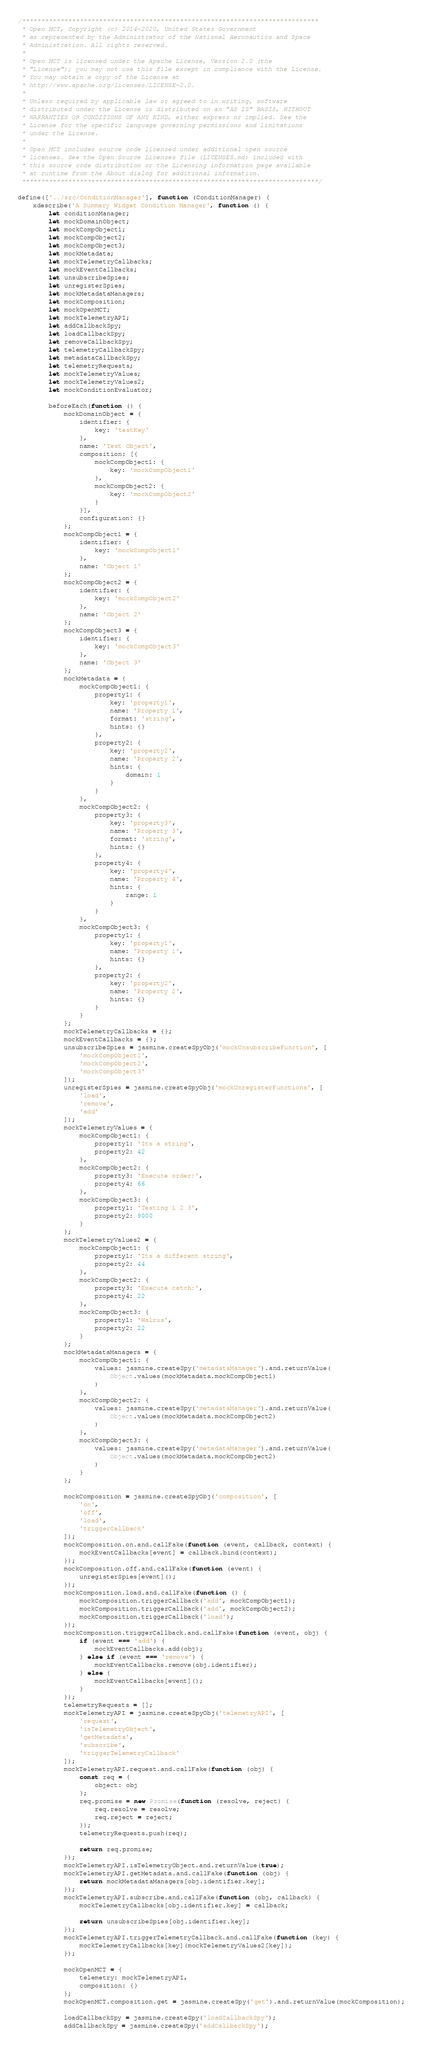Convert code to text. <code><loc_0><loc_0><loc_500><loc_500><_JavaScript_>/*****************************************************************************
 * Open MCT, Copyright (c) 2014-2020, United States Government
 * as represented by the Administrator of the National Aeronautics and Space
 * Administration. All rights reserved.
 *
 * Open MCT is licensed under the Apache License, Version 2.0 (the
 * "License"); you may not use this file except in compliance with the License.
 * You may obtain a copy of the License at
 * http://www.apache.org/licenses/LICENSE-2.0.
 *
 * Unless required by applicable law or agreed to in writing, software
 * distributed under the License is distributed on an "AS IS" BASIS, WITHOUT
 * WARRANTIES OR CONDITIONS OF ANY KIND, either express or implied. See the
 * License for the specific language governing permissions and limitations
 * under the License.
 *
 * Open MCT includes source code licensed under additional open source
 * licenses. See the Open Source Licenses file (LICENSES.md) included with
 * this source code distribution or the Licensing information page available
 * at runtime from the About dialog for additional information.
 *****************************************************************************/

define(['../src/ConditionManager'], function (ConditionManager) {
    xdescribe('A Summary Widget Condition Manager', function () {
        let conditionManager;
        let mockDomainObject;
        let mockCompObject1;
        let mockCompObject2;
        let mockCompObject3;
        let mockMetadata;
        let mockTelemetryCallbacks;
        let mockEventCallbacks;
        let unsubscribeSpies;
        let unregisterSpies;
        let mockMetadataManagers;
        let mockComposition;
        let mockOpenMCT;
        let mockTelemetryAPI;
        let addCallbackSpy;
        let loadCallbackSpy;
        let removeCallbackSpy;
        let telemetryCallbackSpy;
        let metadataCallbackSpy;
        let telemetryRequests;
        let mockTelemetryValues;
        let mockTelemetryValues2;
        let mockConditionEvaluator;

        beforeEach(function () {
            mockDomainObject = {
                identifier: {
                    key: 'testKey'
                },
                name: 'Test Object',
                composition: [{
                    mockCompObject1: {
                        key: 'mockCompObject1'
                    },
                    mockCompObject2: {
                        key: 'mockCompObject2'
                    }
                }],
                configuration: {}
            };
            mockCompObject1 = {
                identifier: {
                    key: 'mockCompObject1'
                },
                name: 'Object 1'
            };
            mockCompObject2 = {
                identifier: {
                    key: 'mockCompObject2'
                },
                name: 'Object 2'
            };
            mockCompObject3 = {
                identifier: {
                    key: 'mockCompObject3'
                },
                name: 'Object 3'
            };
            mockMetadata = {
                mockCompObject1: {
                    property1: {
                        key: 'property1',
                        name: 'Property 1',
                        format: 'string',
                        hints: {}
                    },
                    property2: {
                        key: 'property2',
                        name: 'Property 2',
                        hints: {
                            domain: 1
                        }
                    }
                },
                mockCompObject2: {
                    property3: {
                        key: 'property3',
                        name: 'Property 3',
                        format: 'string',
                        hints: {}
                    },
                    property4: {
                        key: 'property4',
                        name: 'Property 4',
                        hints: {
                            range: 1
                        }
                    }
                },
                mockCompObject3: {
                    property1: {
                        key: 'property1',
                        name: 'Property 1',
                        hints: {}
                    },
                    property2: {
                        key: 'property2',
                        name: 'Property 2',
                        hints: {}
                    }
                }
            };
            mockTelemetryCallbacks = {};
            mockEventCallbacks = {};
            unsubscribeSpies = jasmine.createSpyObj('mockUnsubscribeFunction', [
                'mockCompObject1',
                'mockCompObject2',
                'mockCompObject3'
            ]);
            unregisterSpies = jasmine.createSpyObj('mockUnregisterFunctions', [
                'load',
                'remove',
                'add'
            ]);
            mockTelemetryValues = {
                mockCompObject1: {
                    property1: 'Its a string',
                    property2: 42
                },
                mockCompObject2: {
                    property3: 'Execute order:',
                    property4: 66
                },
                mockCompObject3: {
                    property1: 'Testing 1 2 3',
                    property2: 9000
                }
            };
            mockTelemetryValues2 = {
                mockCompObject1: {
                    property1: 'Its a different string',
                    property2: 44
                },
                mockCompObject2: {
                    property3: 'Execute catch:',
                    property4: 22
                },
                mockCompObject3: {
                    property1: 'Walrus',
                    property2: 22
                }
            };
            mockMetadataManagers = {
                mockCompObject1: {
                    values: jasmine.createSpy('metadataManager').and.returnValue(
                        Object.values(mockMetadata.mockCompObject1)
                    )
                },
                mockCompObject2: {
                    values: jasmine.createSpy('metadataManager').and.returnValue(
                        Object.values(mockMetadata.mockCompObject2)
                    )
                },
                mockCompObject3: {
                    values: jasmine.createSpy('metadataManager').and.returnValue(
                        Object.values(mockMetadata.mockCompObject2)
                    )
                }
            };

            mockComposition = jasmine.createSpyObj('composition', [
                'on',
                'off',
                'load',
                'triggerCallback'
            ]);
            mockComposition.on.and.callFake(function (event, callback, context) {
                mockEventCallbacks[event] = callback.bind(context);
            });
            mockComposition.off.and.callFake(function (event) {
                unregisterSpies[event]();
            });
            mockComposition.load.and.callFake(function () {
                mockComposition.triggerCallback('add', mockCompObject1);
                mockComposition.triggerCallback('add', mockCompObject2);
                mockComposition.triggerCallback('load');
            });
            mockComposition.triggerCallback.and.callFake(function (event, obj) {
                if (event === 'add') {
                    mockEventCallbacks.add(obj);
                } else if (event === 'remove') {
                    mockEventCallbacks.remove(obj.identifier);
                } else {
                    mockEventCallbacks[event]();
                }
            });
            telemetryRequests = [];
            mockTelemetryAPI = jasmine.createSpyObj('telemetryAPI', [
                'request',
                'isTelemetryObject',
                'getMetadata',
                'subscribe',
                'triggerTelemetryCallback'
            ]);
            mockTelemetryAPI.request.and.callFake(function (obj) {
                const req = {
                    object: obj
                };
                req.promise = new Promise(function (resolve, reject) {
                    req.resolve = resolve;
                    req.reject = reject;
                });
                telemetryRequests.push(req);

                return req.promise;
            });
            mockTelemetryAPI.isTelemetryObject.and.returnValue(true);
            mockTelemetryAPI.getMetadata.and.callFake(function (obj) {
                return mockMetadataManagers[obj.identifier.key];
            });
            mockTelemetryAPI.subscribe.and.callFake(function (obj, callback) {
                mockTelemetryCallbacks[obj.identifier.key] = callback;

                return unsubscribeSpies[obj.identifier.key];
            });
            mockTelemetryAPI.triggerTelemetryCallback.and.callFake(function (key) {
                mockTelemetryCallbacks[key](mockTelemetryValues2[key]);
            });

            mockOpenMCT = {
                telemetry: mockTelemetryAPI,
                composition: {}
            };
            mockOpenMCT.composition.get = jasmine.createSpy('get').and.returnValue(mockComposition);

            loadCallbackSpy = jasmine.createSpy('loadCallbackSpy');
            addCallbackSpy = jasmine.createSpy('addCallbackSpy');</code> 